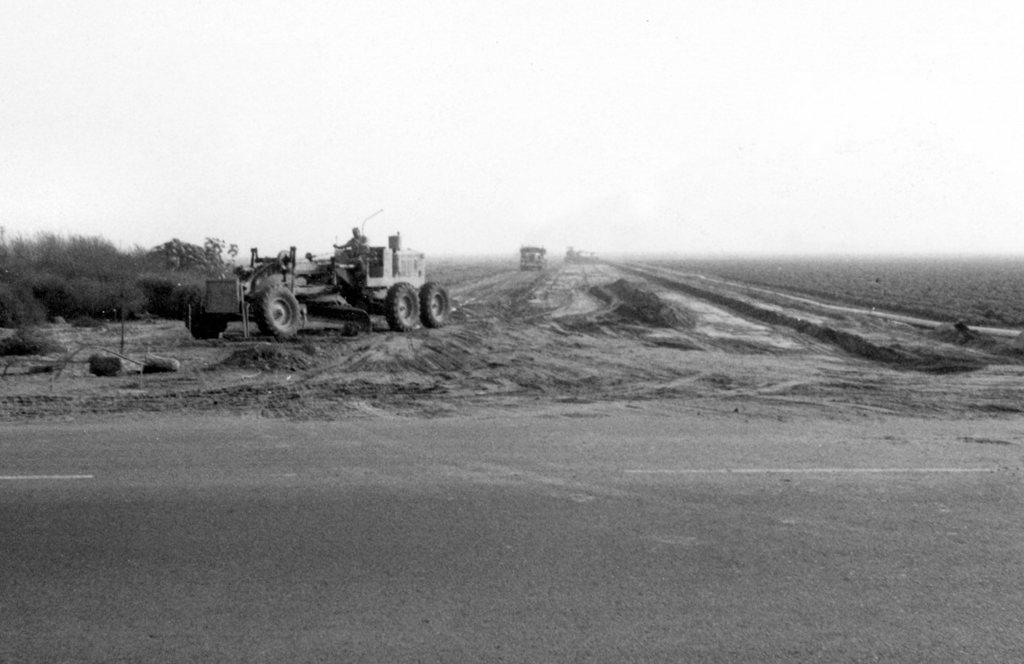What is the color scheme of the image? The image is black and white. What can be seen on the left side of the image? There are trees on the left side of the image. What is happening in the middle of the image? There is a person riding a vehicle on the road. What else can be seen in the background of the image? There are two vehicles and the sky visible in the background of the image. What role does the manager play in the image? There is no mention of a manager in the image, as it features trees, a person riding a vehicle, and two vehicles in the background. 